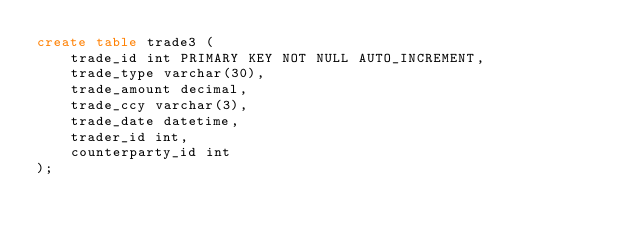Convert code to text. <code><loc_0><loc_0><loc_500><loc_500><_SQL_>create table trade3 (
    trade_id int PRIMARY KEY NOT NULL AUTO_INCREMENT,
    trade_type varchar(30),
    trade_amount decimal,
    trade_ccy varchar(3),
    trade_date datetime,
    trader_id int,
    counterparty_id int
);</code> 